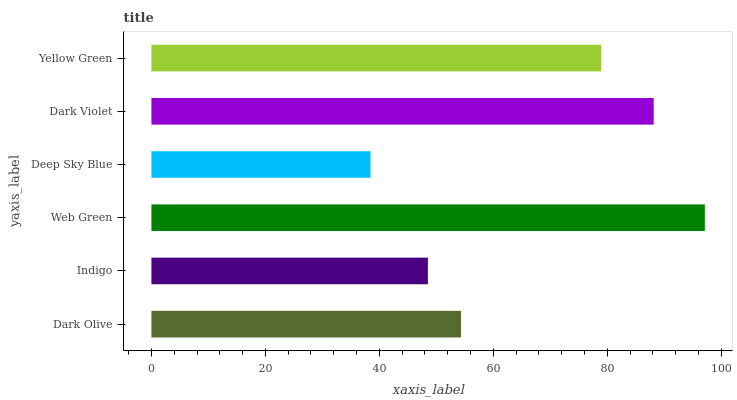Is Deep Sky Blue the minimum?
Answer yes or no. Yes. Is Web Green the maximum?
Answer yes or no. Yes. Is Indigo the minimum?
Answer yes or no. No. Is Indigo the maximum?
Answer yes or no. No. Is Dark Olive greater than Indigo?
Answer yes or no. Yes. Is Indigo less than Dark Olive?
Answer yes or no. Yes. Is Indigo greater than Dark Olive?
Answer yes or no. No. Is Dark Olive less than Indigo?
Answer yes or no. No. Is Yellow Green the high median?
Answer yes or no. Yes. Is Dark Olive the low median?
Answer yes or no. Yes. Is Dark Olive the high median?
Answer yes or no. No. Is Dark Violet the low median?
Answer yes or no. No. 